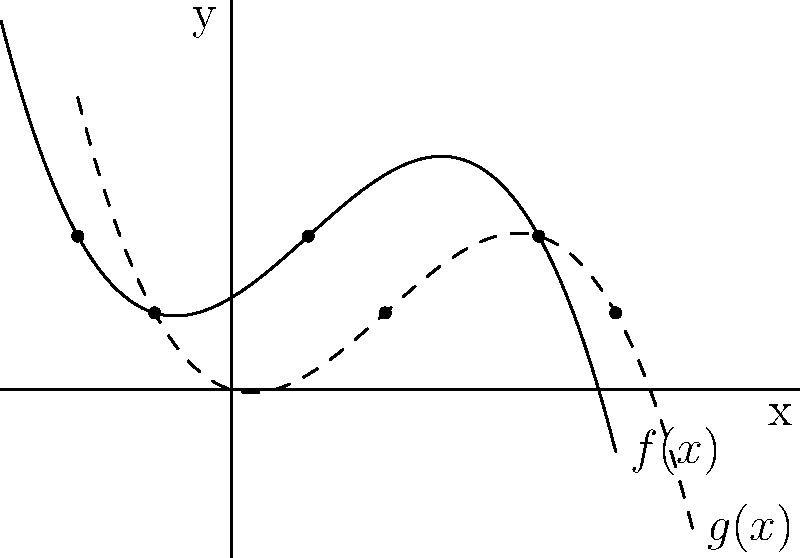In "The Princess Bride," Westley's journey can be represented by the polynomial function $f(x) = -0.1(x+2)(x-1)(x-4)+2$. If the Dread Pirate Roberts transforms Westley's journey by shifting it 1 unit right and 1 unit down, resulting in function $g(x)$, what is the new x-coordinate of the critical point that represents the moment Westley reunites with Buttercup? Let's approach this step-by-step:

1) The original function is $f(x) = -0.1(x+2)(x-1)(x-4)+2$

2) The transformation described is a shift 1 unit right and 1 unit down. This can be represented as:
   $g(x) = f(x-1) - 1$

3) Substituting the original function:
   $g(x) = -0.1((x-1)+2)((x-1)-1)((x-1)-4)+2 - 1$
   $g(x) = -0.1(x+1)(x-2)(x-5)+1$

4) The critical points of $f(x)$ are at $x = -2, 1, 4$

5) The critical point at $x = 1$ in $f(x)$ represents the reunion moment

6) To find the new x-coordinate of this point in $g(x)$, we add 1 to the original x-coordinate:
   New x-coordinate = 1 + 1 = 2

Therefore, the new x-coordinate of the critical point representing the reunion moment in $g(x)$ is 2.
Answer: 2 